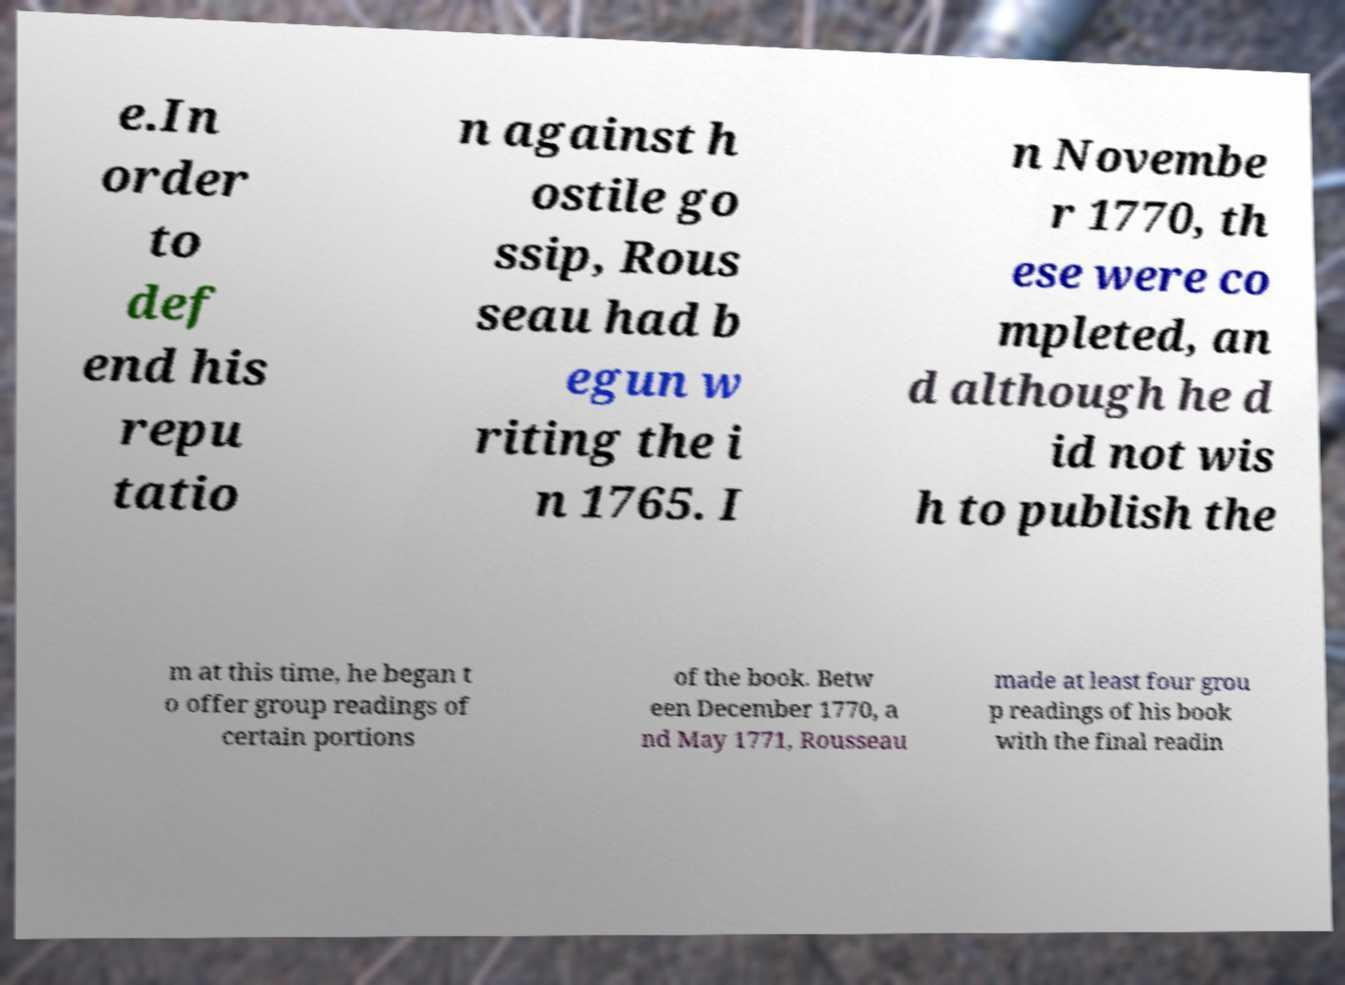Could you assist in decoding the text presented in this image and type it out clearly? e.In order to def end his repu tatio n against h ostile go ssip, Rous seau had b egun w riting the i n 1765. I n Novembe r 1770, th ese were co mpleted, an d although he d id not wis h to publish the m at this time, he began t o offer group readings of certain portions of the book. Betw een December 1770, a nd May 1771, Rousseau made at least four grou p readings of his book with the final readin 